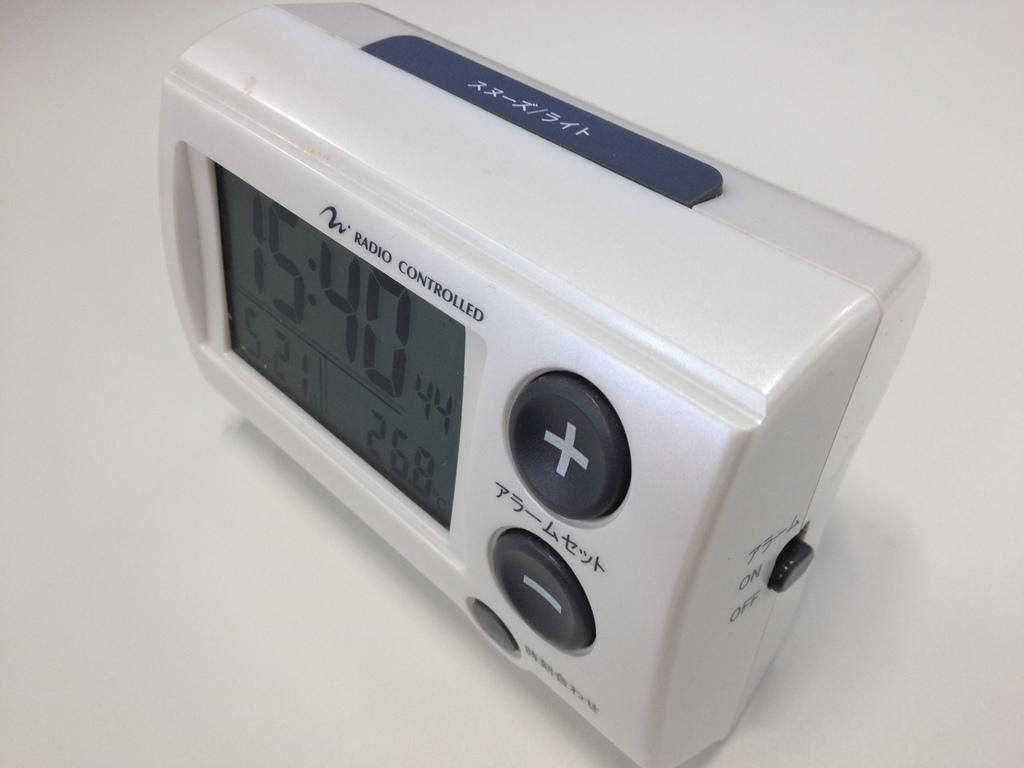<image>
Summarize the visual content of the image. A digital clock displaying a time of 15:40 